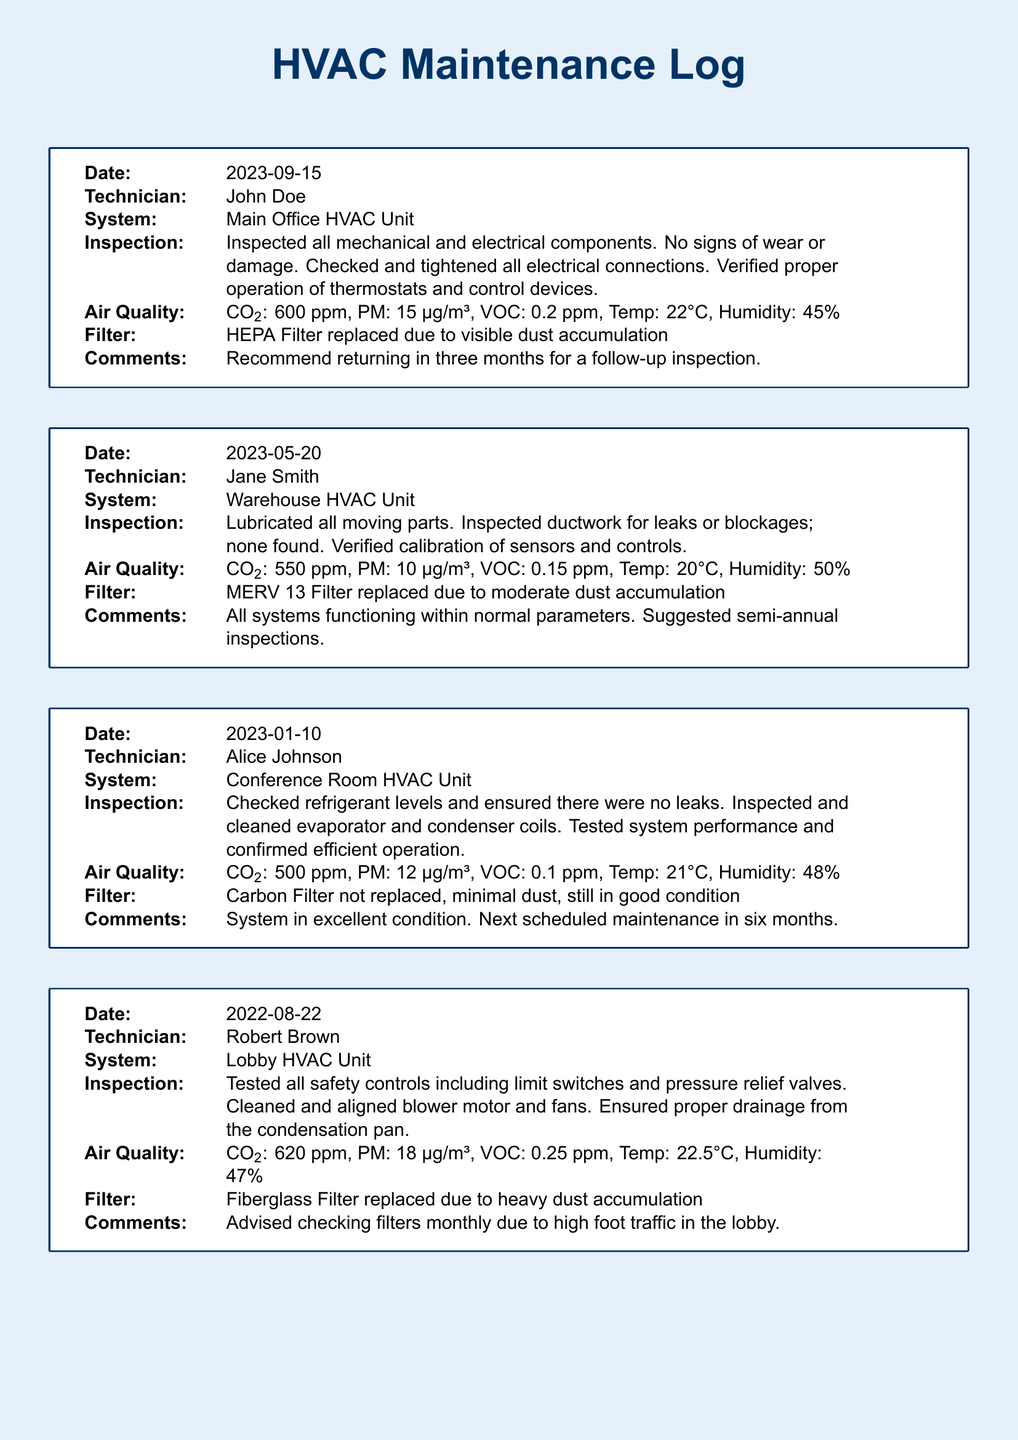What is the date of the latest inspection? The latest inspection was conducted on 2023-09-15, as noted in the maintenance log.
Answer: 2023-09-15 Who performed the inspection on the Lobby HVAC Unit? The inspection for the Lobby HVAC Unit was performed by Robert Brown, as indicated in the document.
Answer: Robert Brown What was the CO2 level reported during the Conference Room HVAC inspection? The CO2 level reported during the Conference Room HVAC inspection was 500 ppm.
Answer: 500 ppm Which HVAC unit had a filter replaced due to heavy dust accumulation? The Lobby HVAC Unit had its fiberglass filter replaced due to heavy dust accumulation, according to the inspection records.
Answer: Lobby HVAC Unit What is the recommended follow-up period for the Main Office HVAC Unit? The maintenance log states a recommendation for a follow-up inspection in three months for the Main Office HVAC Unit.
Answer: Three months What air quality measurement was taken for PM during the Warehouse HVAC Unit inspection? The PM measurement taken during the Warehouse HVAC Unit inspection was 10 µg/m³.
Answer: 10 µg/m³ What type of filter was replaced in the Main Office HVAC Unit? The HEPA Filter was replaced in the Main Office HVAC Unit due to visible dust accumulation.
Answer: HEPA Filter How often does the technician suggest checking filters for the Lobby HVAC Unit? The technician advised checking filters monthly due to high foot traffic in the lobby.
Answer: Monthly 